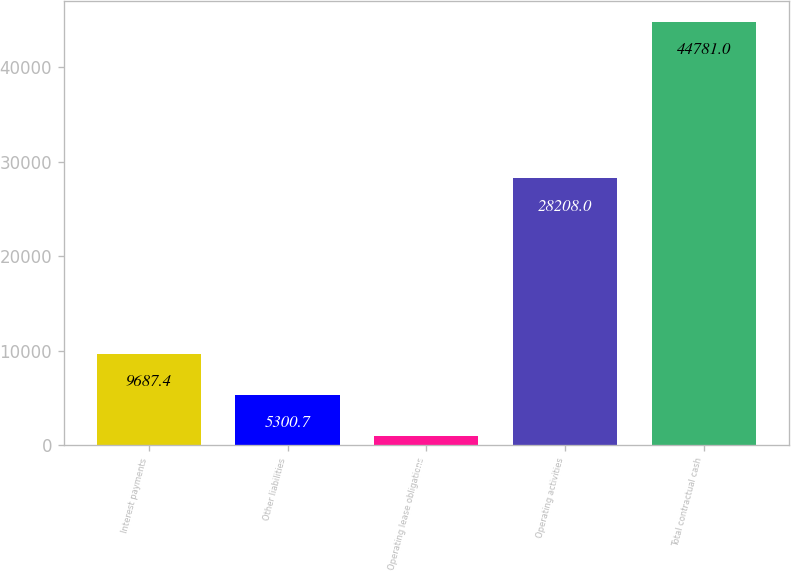<chart> <loc_0><loc_0><loc_500><loc_500><bar_chart><fcel>Interest payments<fcel>Other liabilities<fcel>Operating lease obligations<fcel>Operating activities<fcel>Total contractual cash<nl><fcel>9687.4<fcel>5300.7<fcel>914<fcel>28208<fcel>44781<nl></chart> 